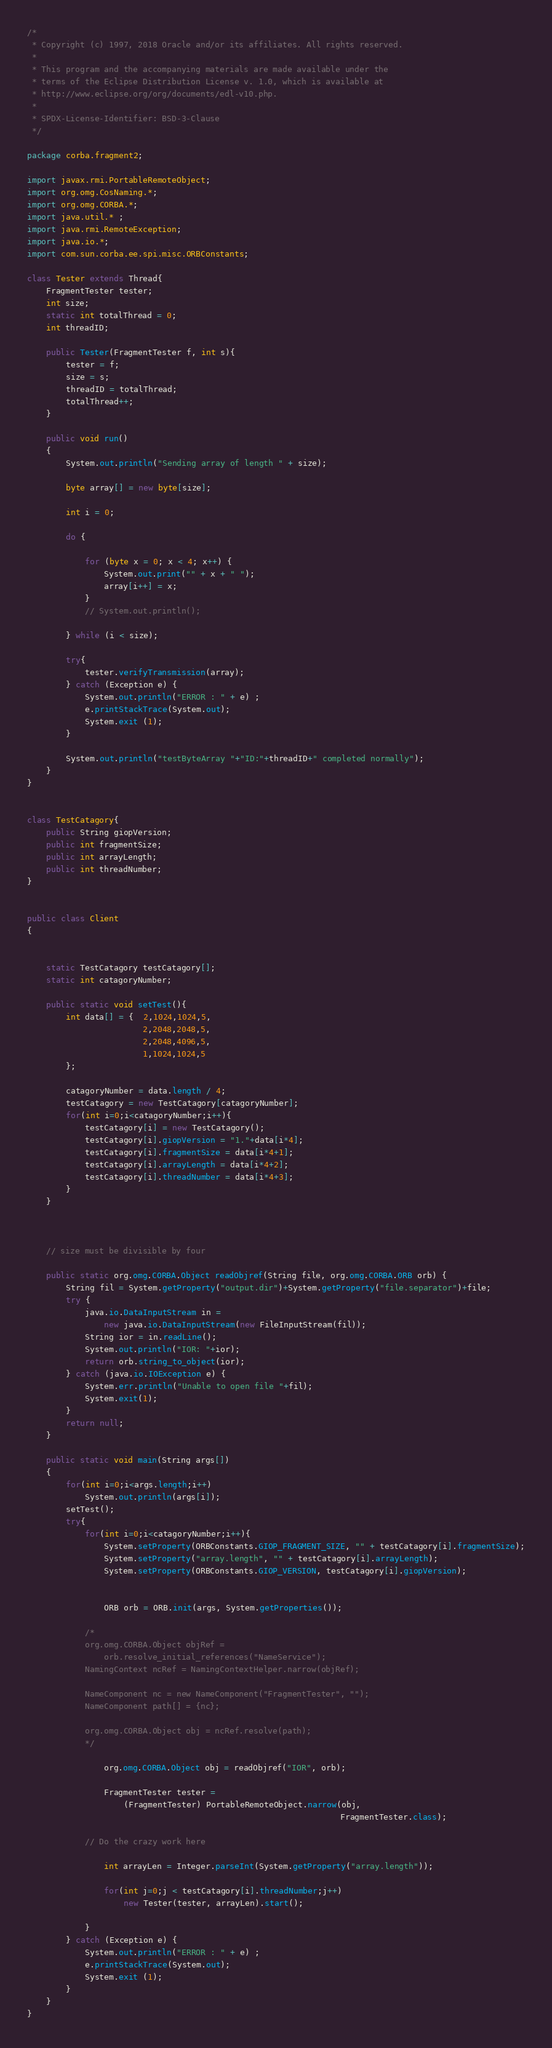<code> <loc_0><loc_0><loc_500><loc_500><_Java_>/*
 * Copyright (c) 1997, 2018 Oracle and/or its affiliates. All rights reserved.
 *
 * This program and the accompanying materials are made available under the
 * terms of the Eclipse Distribution License v. 1.0, which is available at
 * http://www.eclipse.org/org/documents/edl-v10.php.
 *
 * SPDX-License-Identifier: BSD-3-Clause
 */

package corba.fragment2;

import javax.rmi.PortableRemoteObject;
import org.omg.CosNaming.*;
import org.omg.CORBA.*;
import java.util.* ;
import java.rmi.RemoteException;
import java.io.*;
import com.sun.corba.ee.spi.misc.ORBConstants;

class Tester extends Thread{
    FragmentTester tester;
    int size;
    static int totalThread = 0;
    int threadID;

    public Tester(FragmentTester f, int s){
        tester = f;
        size = s;
        threadID = totalThread;
        totalThread++;
    }

    public void run() 
    {
        System.out.println("Sending array of length " + size);

        byte array[] = new byte[size];

        int i = 0;

        do {

            for (byte x = 0; x < 4; x++) {
                System.out.print("" + x + " ");
                array[i++] = x;
            }
            // System.out.println();

        } while (i < size);

        try{
            tester.verifyTransmission(array);
        } catch (Exception e) {
            System.out.println("ERROR : " + e) ;
            e.printStackTrace(System.out);
            System.exit (1);
        }

        System.out.println("testByteArray "+"ID:"+threadID+" completed normally");
    }
}


class TestCatagory{
    public String giopVersion;
    public int fragmentSize;
    public int arrayLength;
    public int threadNumber;
}


public class Client
{


    static TestCatagory testCatagory[];
    static int catagoryNumber;

    public static void setTest(){
        int data[] = {  2,1024,1024,5,
                        2,2048,2048,5,
                        2,2048,4096,5,
                        1,1024,1024,5
        };

        catagoryNumber = data.length / 4;
        testCatagory = new TestCatagory[catagoryNumber];
        for(int i=0;i<catagoryNumber;i++){
            testCatagory[i] = new TestCatagory();
            testCatagory[i].giopVersion = "1."+data[i*4];
            testCatagory[i].fragmentSize = data[i*4+1];
            testCatagory[i].arrayLength = data[i*4+2];
            testCatagory[i].threadNumber = data[i*4+3];
        }
    }   

        

    // size must be divisible by four

    public static org.omg.CORBA.Object readObjref(String file, org.omg.CORBA.ORB orb) {
        String fil = System.getProperty("output.dir")+System.getProperty("file.separator")+file;
        try {
            java.io.DataInputStream in = 
                new java.io.DataInputStream(new FileInputStream(fil));
            String ior = in.readLine();
            System.out.println("IOR: "+ior);
            return orb.string_to_object(ior);
        } catch (java.io.IOException e) {
            System.err.println("Unable to open file "+fil);
            System.exit(1);
        }
        return null;
    }

    public static void main(String args[])
    {
        for(int i=0;i<args.length;i++)
            System.out.println(args[i]);
        setTest();
        try{
            for(int i=0;i<catagoryNumber;i++){
                System.setProperty(ORBConstants.GIOP_FRAGMENT_SIZE, "" + testCatagory[i].fragmentSize);
                System.setProperty("array.length", "" + testCatagory[i].arrayLength);
                System.setProperty(ORBConstants.GIOP_VERSION, testCatagory[i].giopVersion);


                ORB orb = ORB.init(args, System.getProperties());

            /*
            org.omg.CORBA.Object objRef = 
                orb.resolve_initial_references("NameService");
            NamingContext ncRef = NamingContextHelper.narrow(objRef);
 
            NameComponent nc = new NameComponent("FragmentTester", "");
            NameComponent path[] = {nc};

            org.omg.CORBA.Object obj = ncRef.resolve(path);
            */

                org.omg.CORBA.Object obj = readObjref("IOR", orb);

                FragmentTester tester = 
                    (FragmentTester) PortableRemoteObject.narrow(obj, 
                                                                 FragmentTester.class);

            // Do the crazy work here

                int arrayLen = Integer.parseInt(System.getProperty("array.length"));

                for(int j=0;j < testCatagory[i].threadNumber;j++)
                    new Tester(tester, arrayLen).start();

            }
        } catch (Exception e) {
            System.out.println("ERROR : " + e) ;
            e.printStackTrace(System.out);
            System.exit (1);
        }
    }
}
</code> 